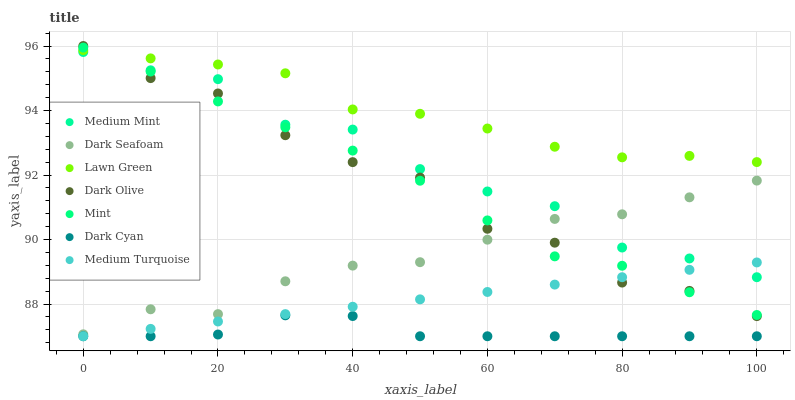Does Dark Cyan have the minimum area under the curve?
Answer yes or no. Yes. Does Lawn Green have the maximum area under the curve?
Answer yes or no. Yes. Does Dark Olive have the minimum area under the curve?
Answer yes or no. No. Does Dark Olive have the maximum area under the curve?
Answer yes or no. No. Is Medium Turquoise the smoothest?
Answer yes or no. Yes. Is Dark Olive the roughest?
Answer yes or no. Yes. Is Lawn Green the smoothest?
Answer yes or no. No. Is Lawn Green the roughest?
Answer yes or no. No. Does Medium Turquoise have the lowest value?
Answer yes or no. Yes. Does Dark Olive have the lowest value?
Answer yes or no. No. Does Dark Olive have the highest value?
Answer yes or no. Yes. Does Lawn Green have the highest value?
Answer yes or no. No. Is Dark Cyan less than Lawn Green?
Answer yes or no. Yes. Is Dark Seafoam greater than Dark Cyan?
Answer yes or no. Yes. Does Medium Turquoise intersect Dark Olive?
Answer yes or no. Yes. Is Medium Turquoise less than Dark Olive?
Answer yes or no. No. Is Medium Turquoise greater than Dark Olive?
Answer yes or no. No. Does Dark Cyan intersect Lawn Green?
Answer yes or no. No. 